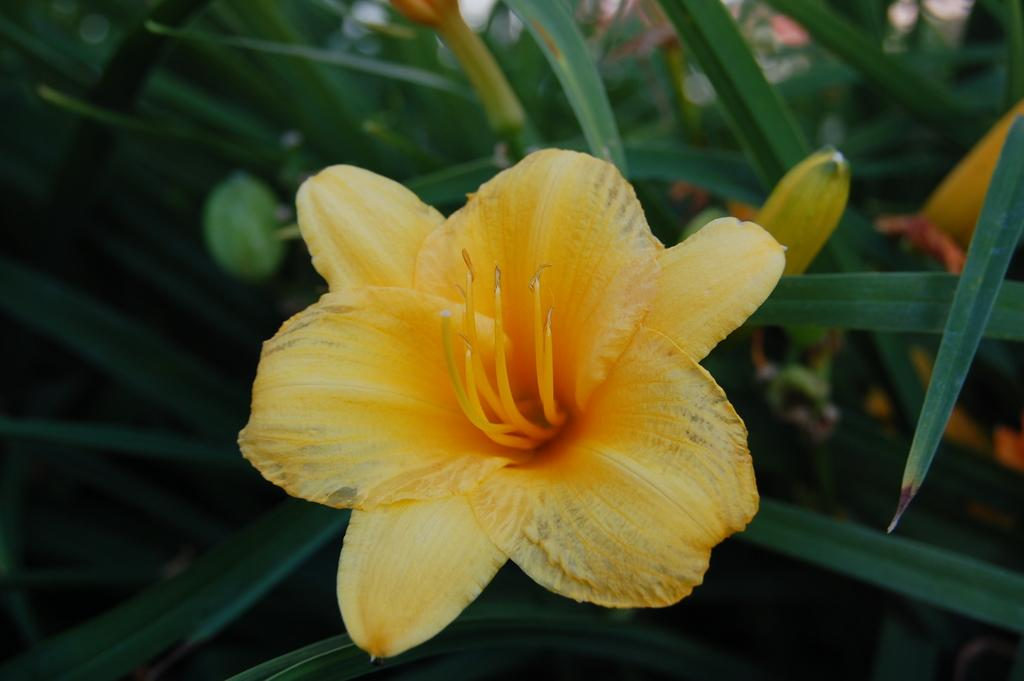What type of plant is featured in the image? There is a plant with a flower in the image. Can you describe the background of the image? There are plants in the background of the image. What type of cactus can be seen in the room in the image? There is no cactus or room present in the image; it features a plant with a flower and plants in the background. 